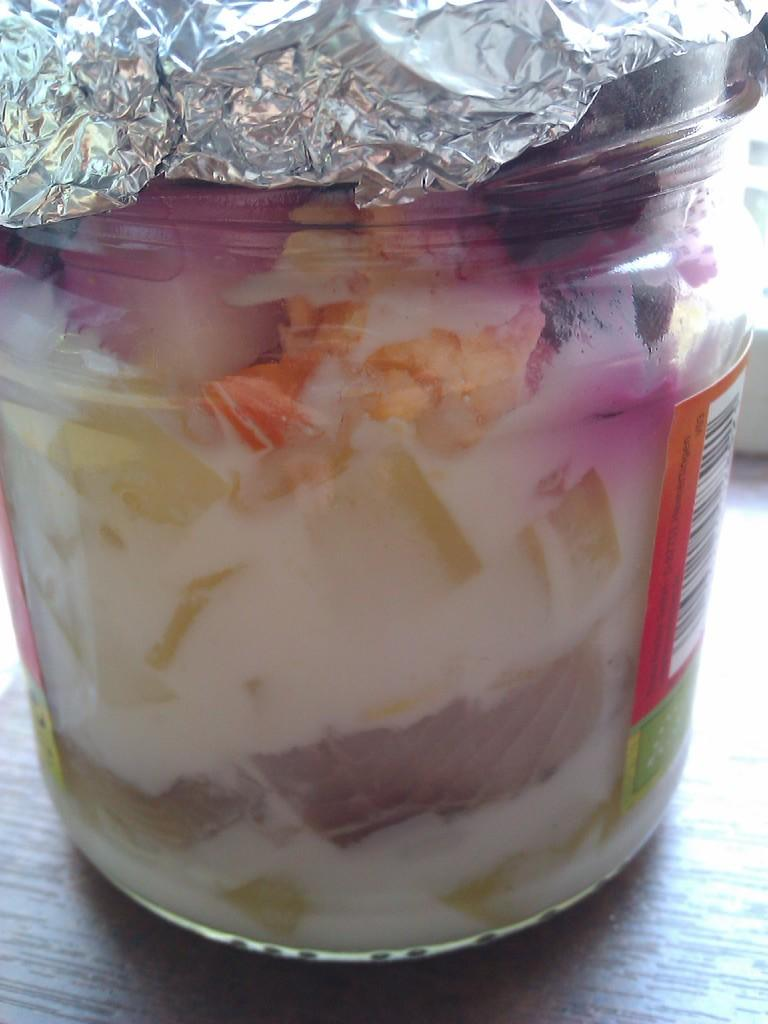What is inside the jar that is visible in the image? There is food in the jar that is visible in the image. What is covering the jar in the image? There is an aluminum foil on the jar. On what surface is the jar placed in the image? The jar is placed on a wooden surface. What type of pleasure can be seen running through the field in the image? There is no pleasure or field present in the image; it features a jar with food, an aluminum foil, and a wooden surface. 